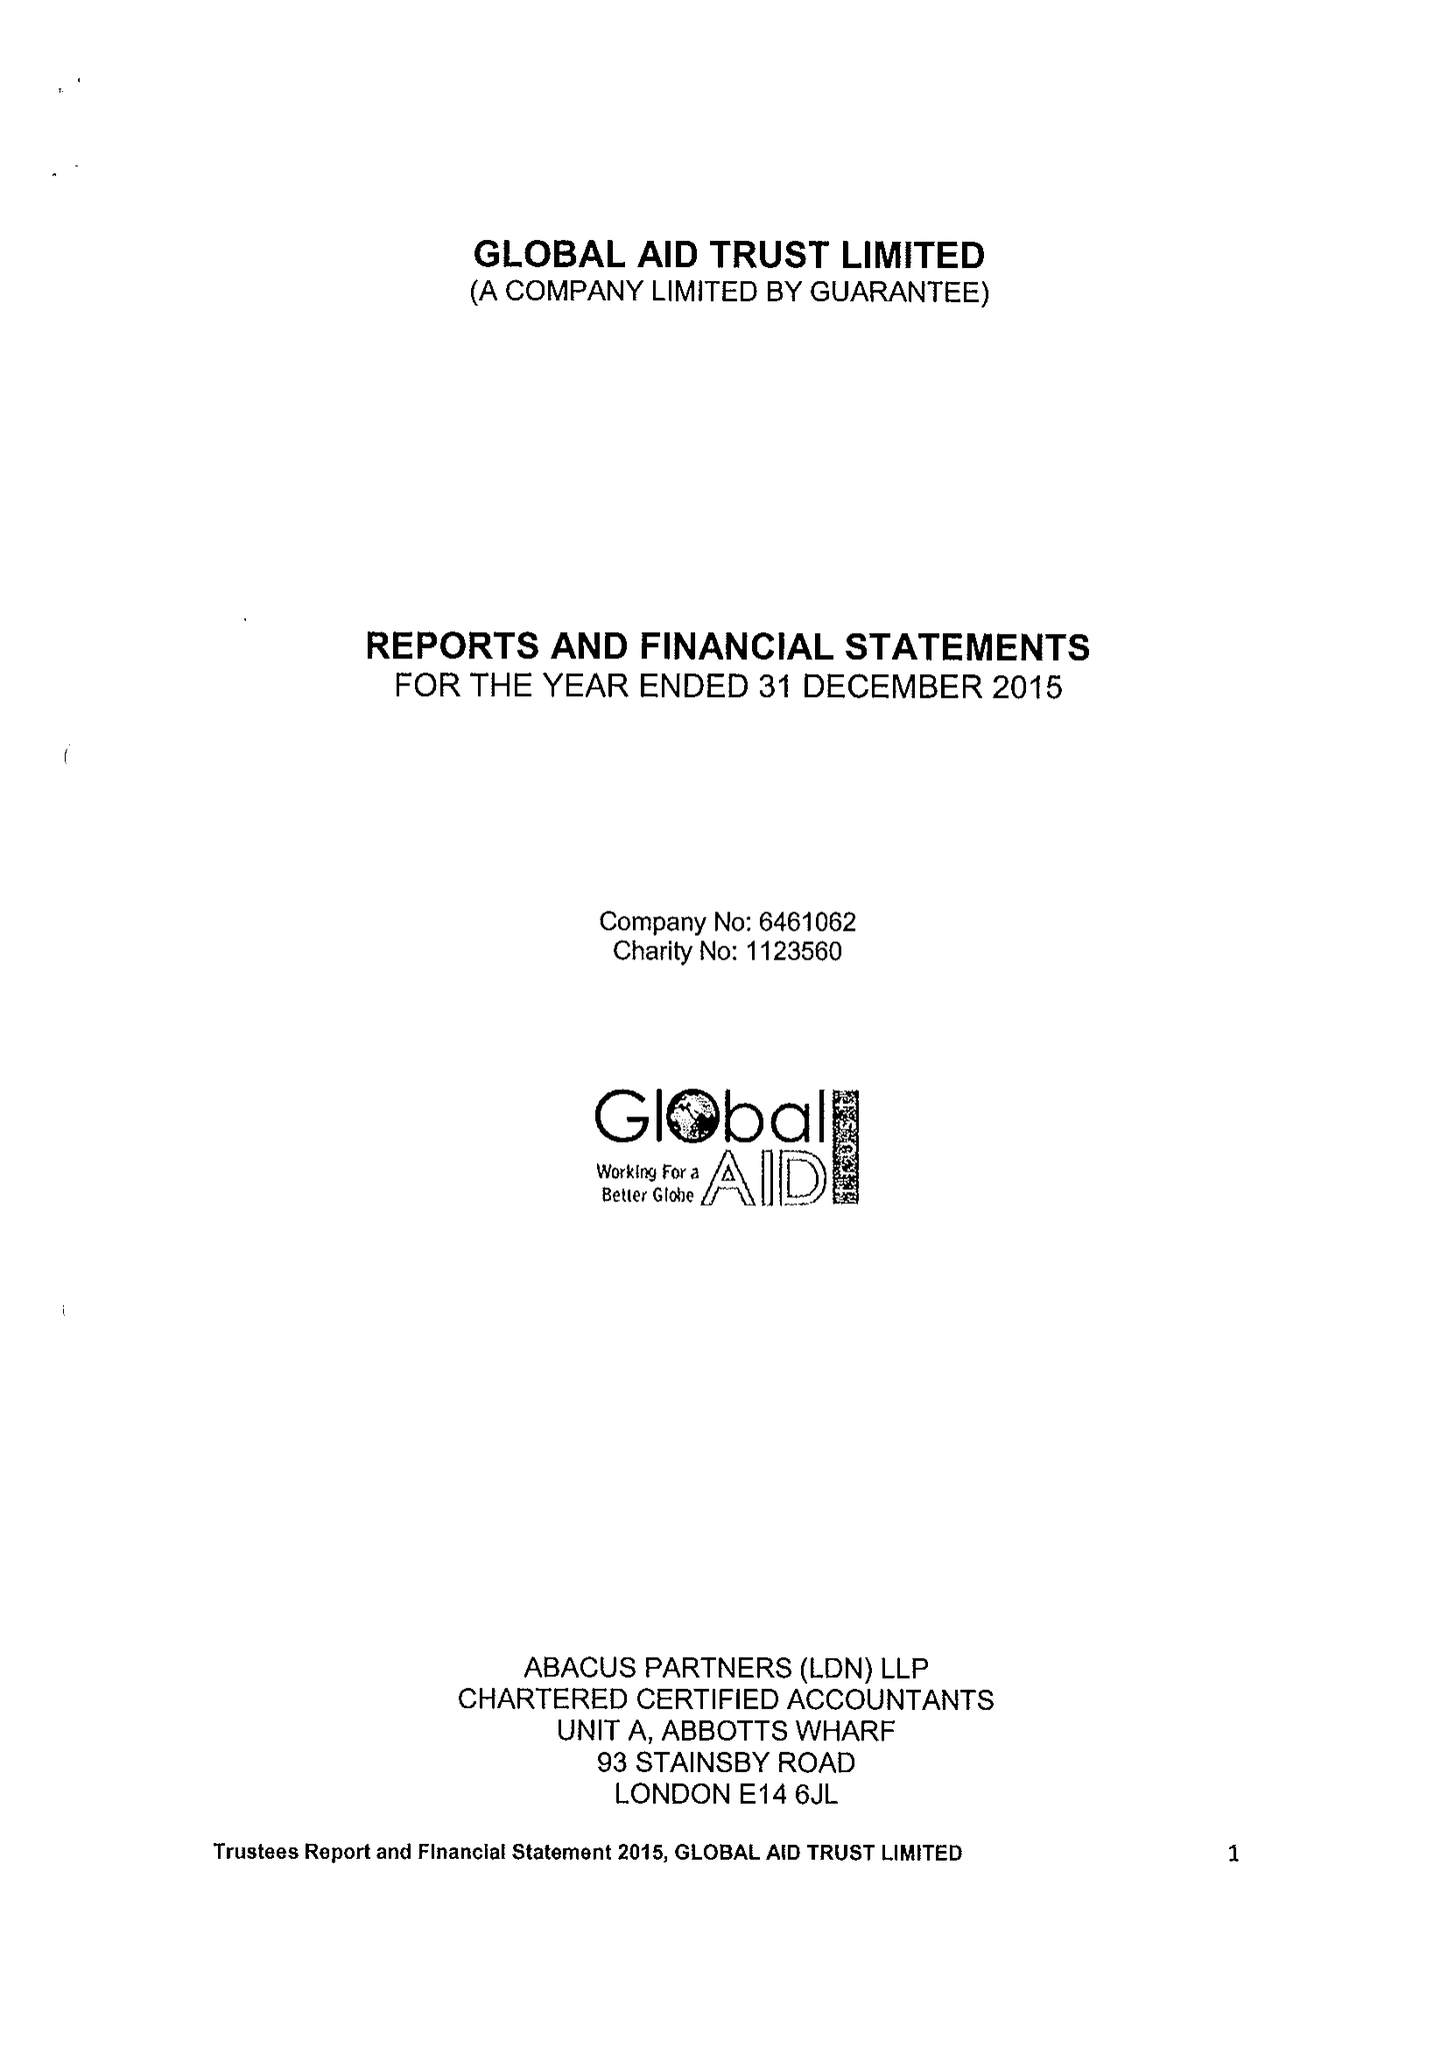What is the value for the address__post_town?
Answer the question using a single word or phrase. LONDON 